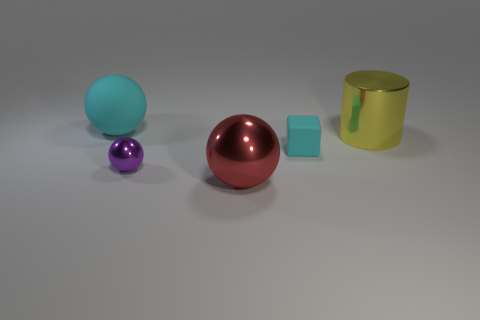Add 2 large spheres. How many objects exist? 7 Subtract all spheres. How many objects are left? 2 Add 1 cylinders. How many cylinders are left? 2 Add 3 large brown shiny cylinders. How many large brown shiny cylinders exist? 3 Subtract 0 red cylinders. How many objects are left? 5 Subtract all large cyan metal cylinders. Subtract all red things. How many objects are left? 4 